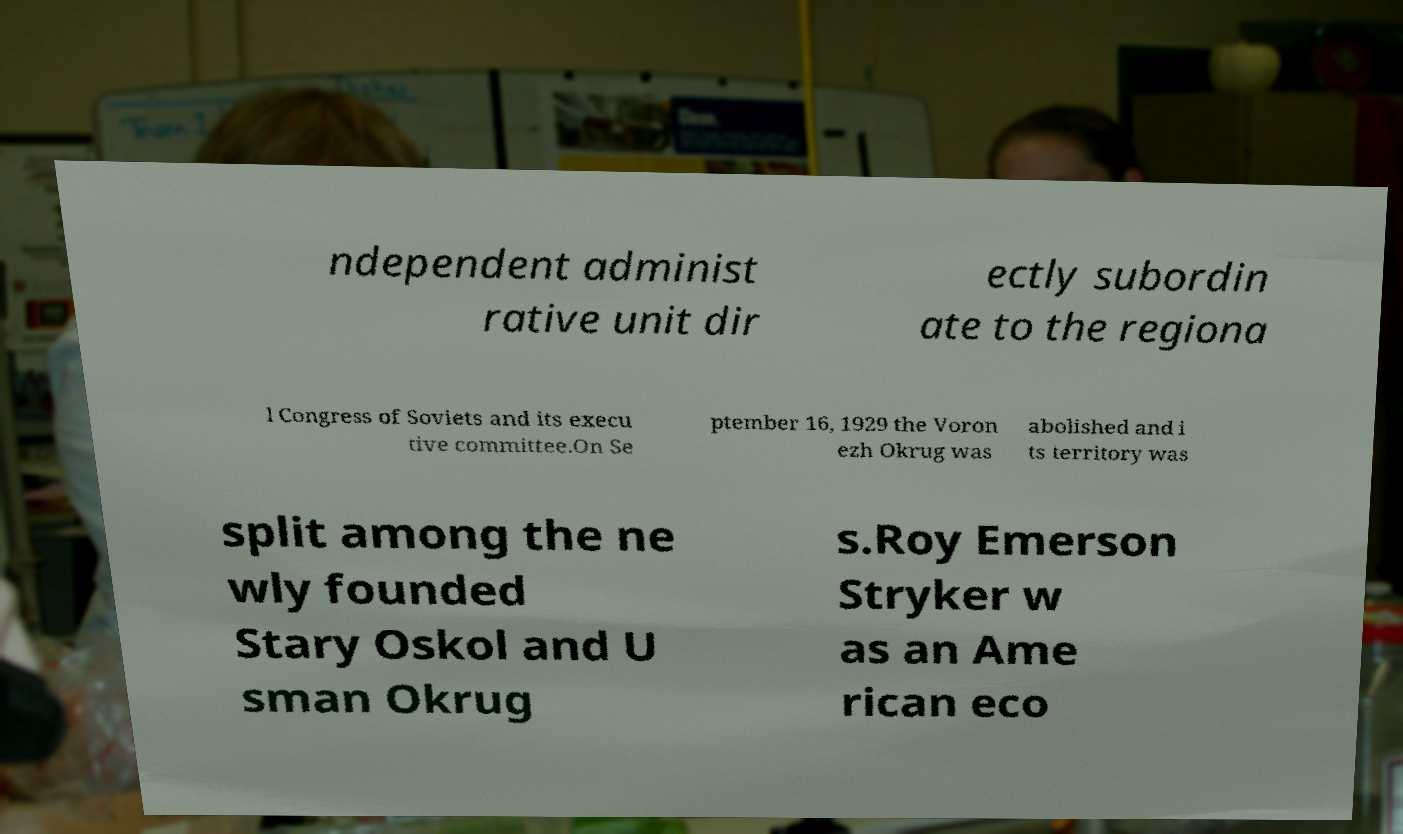For documentation purposes, I need the text within this image transcribed. Could you provide that? ndependent administ rative unit dir ectly subordin ate to the regiona l Congress of Soviets and its execu tive committee.On Se ptember 16, 1929 the Voron ezh Okrug was abolished and i ts territory was split among the ne wly founded Stary Oskol and U sman Okrug s.Roy Emerson Stryker w as an Ame rican eco 